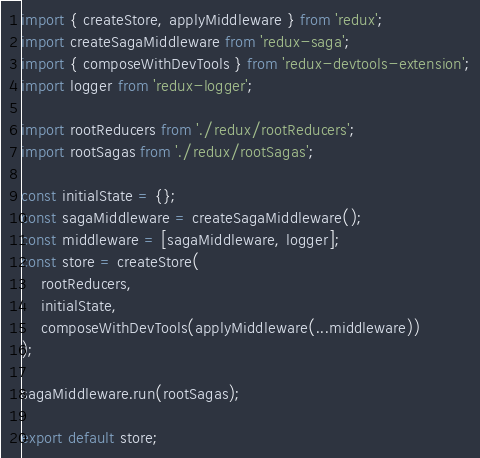<code> <loc_0><loc_0><loc_500><loc_500><_JavaScript_>import { createStore, applyMiddleware } from 'redux';
import createSagaMiddleware from 'redux-saga';
import { composeWithDevTools } from 'redux-devtools-extension';
import logger from 'redux-logger';

import rootReducers from './redux/rootReducers';
import rootSagas from './redux/rootSagas';

const initialState = {};
const sagaMiddleware = createSagaMiddleware();
const middleware = [sagaMiddleware, logger];
const store = createStore(
    rootReducers, 
    initialState,
    composeWithDevTools(applyMiddleware(...middleware)) 
);

sagaMiddleware.run(rootSagas);

export default store;</code> 